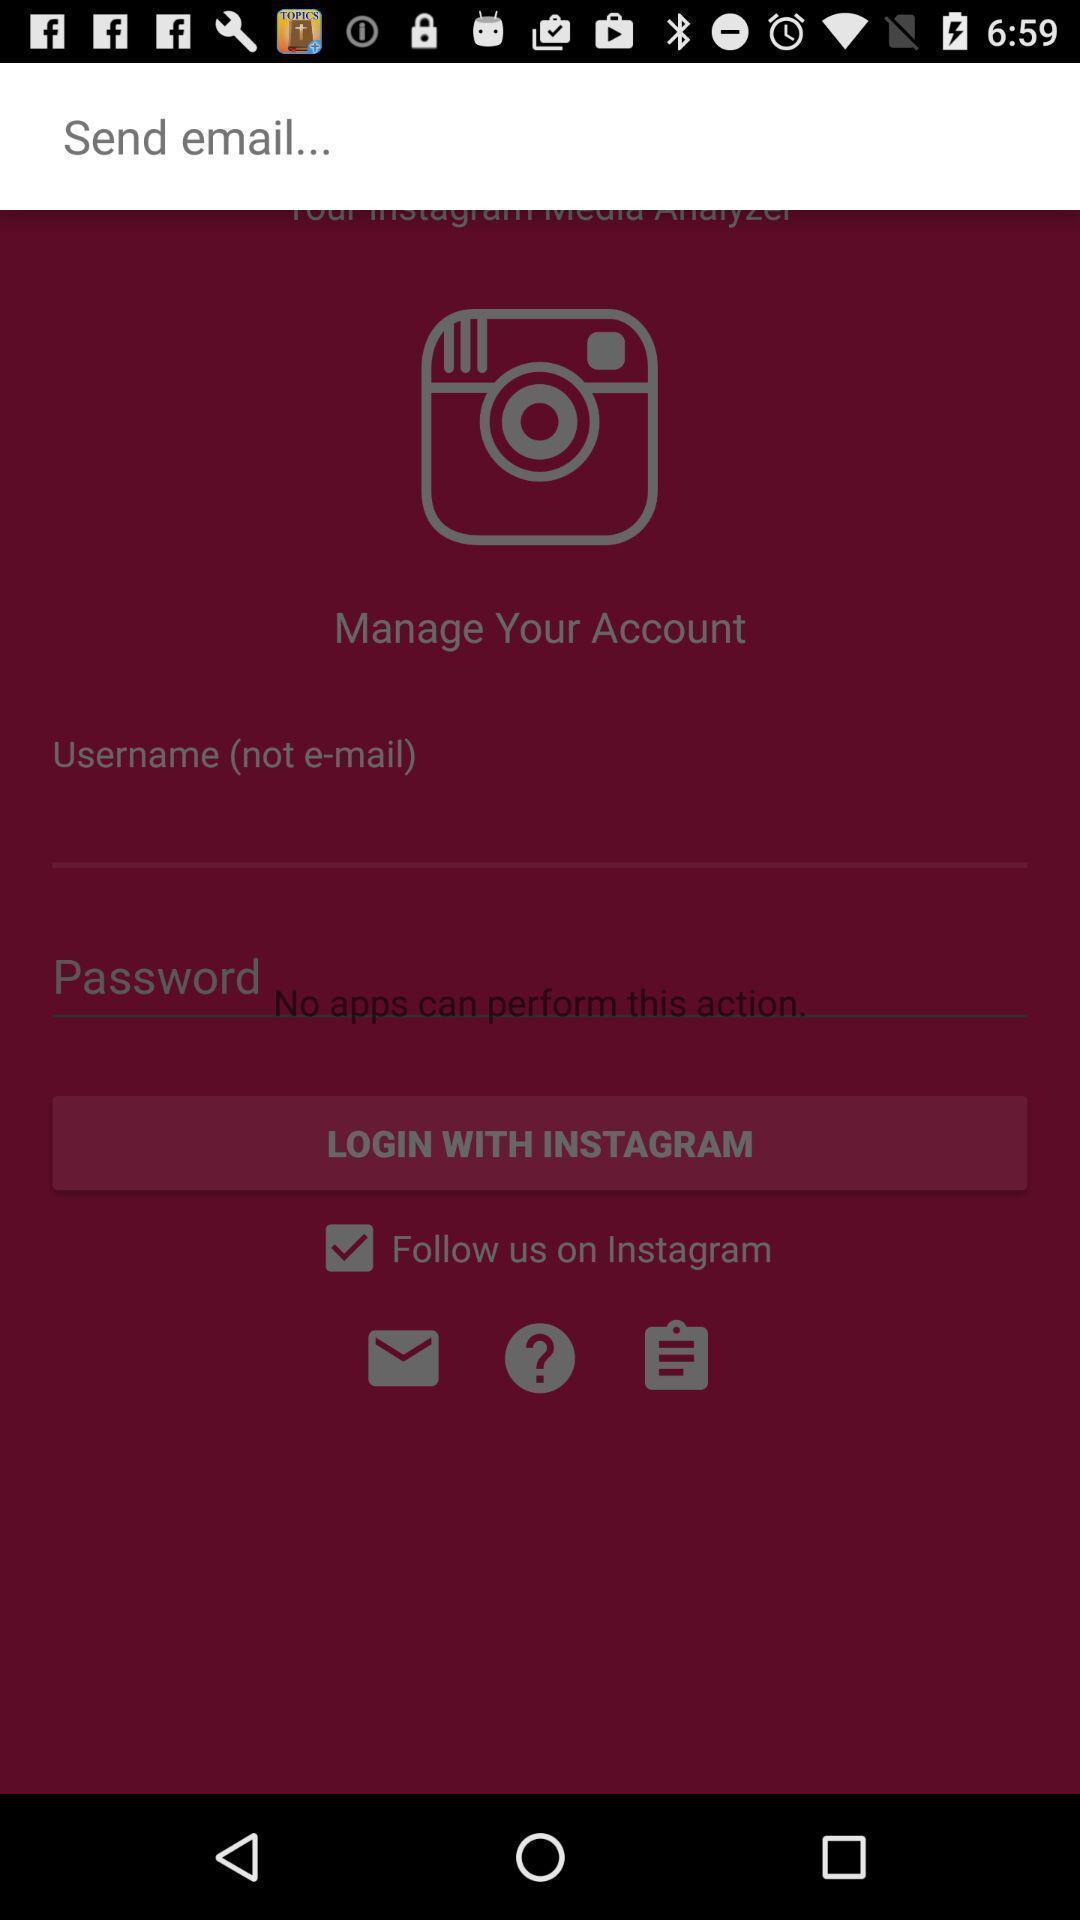Describe the visual elements of this screenshot. Screen displaying contents in login page. 